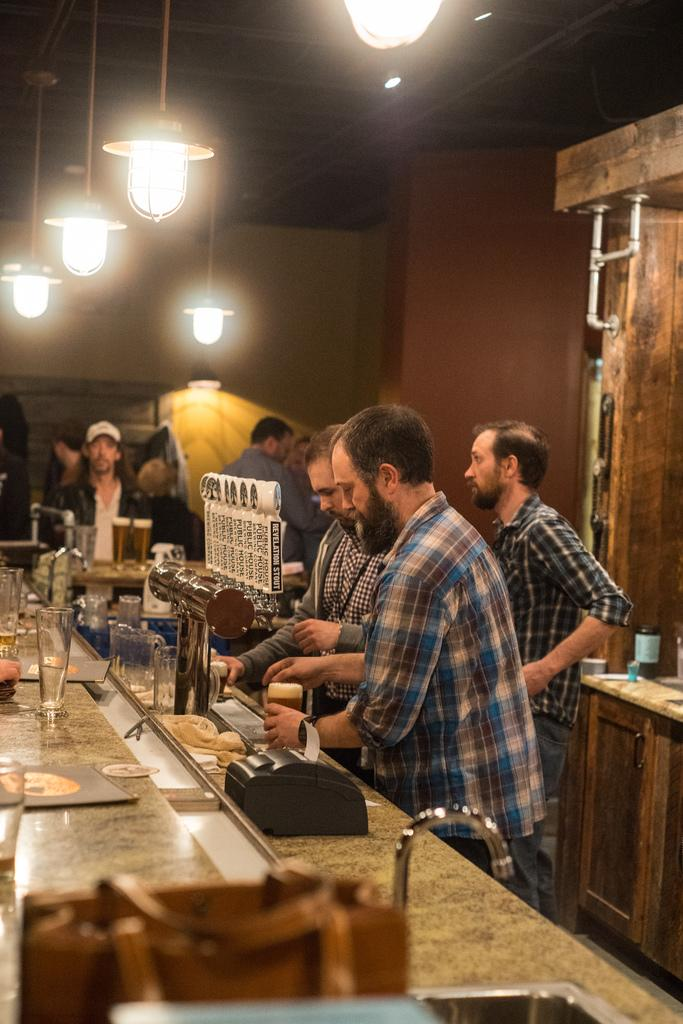Who or what can be seen in the image? There are people in the image. What can be found near the people? There is a sink, a tap, and glasses in the image. What type of appliance is present in the image? There is a machine in the image. What objects are on a table in the image? There are objects on a table in the image. What can be seen illuminating the scene? There are lights visible in the image. What type of storage unit is present in the image? There is a cupboard in the image. What type of background is visible in the image? There is a wall visible in the image. What type of stone is visible in the image? There is no stone visible in the image. What type of business is being conducted in the image? The image does not depict any business activities. 